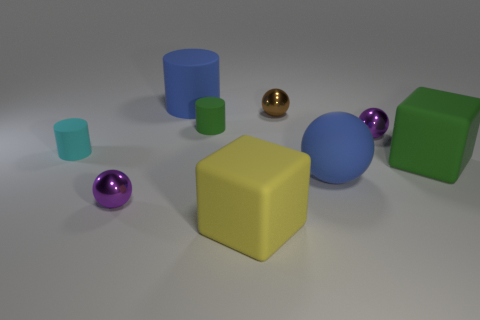What can you infer about the material of the objects? The objects have different finishes indicating they could be made of various materials; the shiny spheres suggest a reflective material like polished metal, while the matte cylinders might be plastic or painted wood. Are there any patterns or consistencies in the arrangement of these objects? There does not appear to be a specific pattern, but the objects are placed in a way that provides a balanced distribution of colors and shapes across the image. 